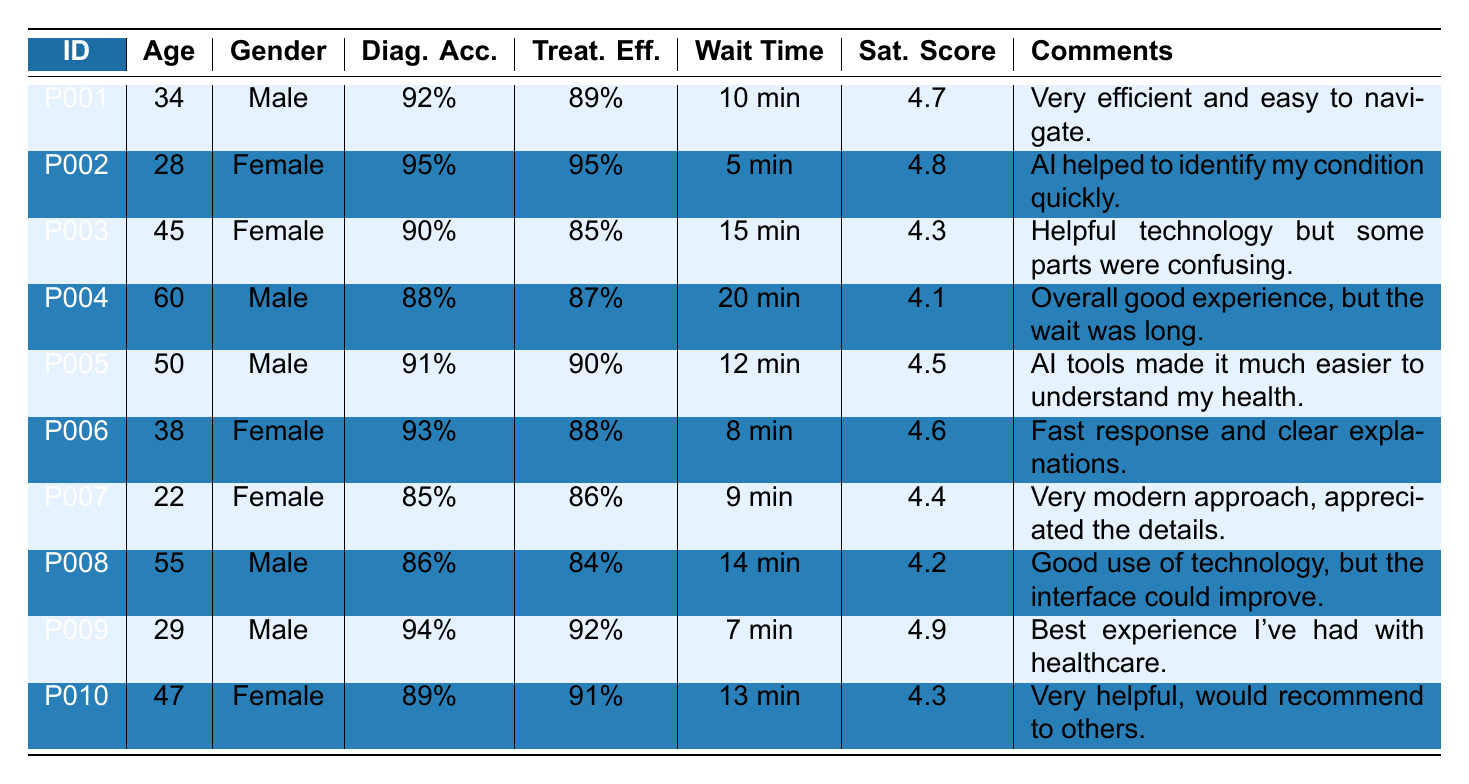What is the highest satisfaction score among the patients? By reviewing the satisfaction scores listed in the table, I see the scores are 4.7, 4.8, 4.3, 4.1, 4.5, 4.6, 4.4, 4.2, 4.9, and 4.3. The highest score is 4.9.
Answer: 4.9 What was the average waiting time for the patients? The waiting times are 10, 5, 15, 20, 12, 8, 9, 14, 7, and 13 minutes. Adding them gives 10 + 5 + 15 + 20 + 12 + 8 + 9 + 14 + 7 + 13 = 123 minutes. Dividing by the number of patients (10) gives an average of 123 / 10 = 12.3 minutes.
Answer: 12.3 minutes Is there a patient who rated their satisfaction score below 4.2? By looking through the satisfaction scores, I see they are all above 4.1. Specifically, P004 has a score of 4.1, which is the lowest, confirming no score is below 4.2.
Answer: No How many females had a diagnosis accuracy of 90% or higher? The female patients are P002 (95%), P003 (90%), P006 (93%), P007 (85%), and P010 (89%). Only P002, P003, and P006 have diagnosis accuracies of 90% or higher. So, there are 3 female patients.
Answer: 3 What is the difference in satisfaction scores between the patient with the highest and the lowest score? The highest satisfaction score is 4.9 (P009) and the lowest is 4.1 (P004). The difference is 4.9 - 4.1 = 0.8.
Answer: 0.8 Which patient had the longest waiting time and what was their satisfaction score? Examining the waiting times, P004 had the longest wait at 20 minutes. Their satisfaction score is 4.1.
Answer: P004, 4.1 What percentage of patients rated their treatment effectiveness at 90% or above? The patients with treatment effectiveness at or above 90% are P002 (95%), P005 (90%), P006 (88%), P009 (92%), and P010 (91%). This is 4 out of 10 patients, giving a percentage of (4 / 10) * 100 = 40%.
Answer: 40% Do more males or females have a satisfaction score higher than 4.5? Male patients with scores higher than 4.5 are P001 (4.7), P005 (4.5), P009 (4.9). Female patients are P002 (4.8), P006 (4.6). Here, 3 males and 2 females have scores higher than 4.5.
Answer: More males What is the median age of the patients surveyed? The ages listed are 34, 28, 45, 60, 50, 38, 22, 55, 29, and 47. Sorting the ages gives 22, 28, 29, 34, 38, 45, 47, 50, 55, 60. Since there are 10 entries, the median is the average of the 5th and 6th ages: (38 + 45)/2 = 41.5.
Answer: 41.5 How many patients provided comments expressing confusion with the AI system? P003 and P008 both mentioned confusion or areas of improvement in their comments. P003 stated it was "confusing," and P008 noted that the "interface could improve." Thus, 2 patients expressed confusion.
Answer: 2 